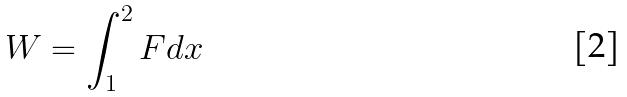Convert formula to latex. <formula><loc_0><loc_0><loc_500><loc_500>W = \int _ { 1 } ^ { 2 } F d x</formula> 